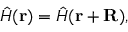Convert formula to latex. <formula><loc_0><loc_0><loc_500><loc_500>\hat { H } ( r ) = \hat { H } ( r + R ) ,</formula> 